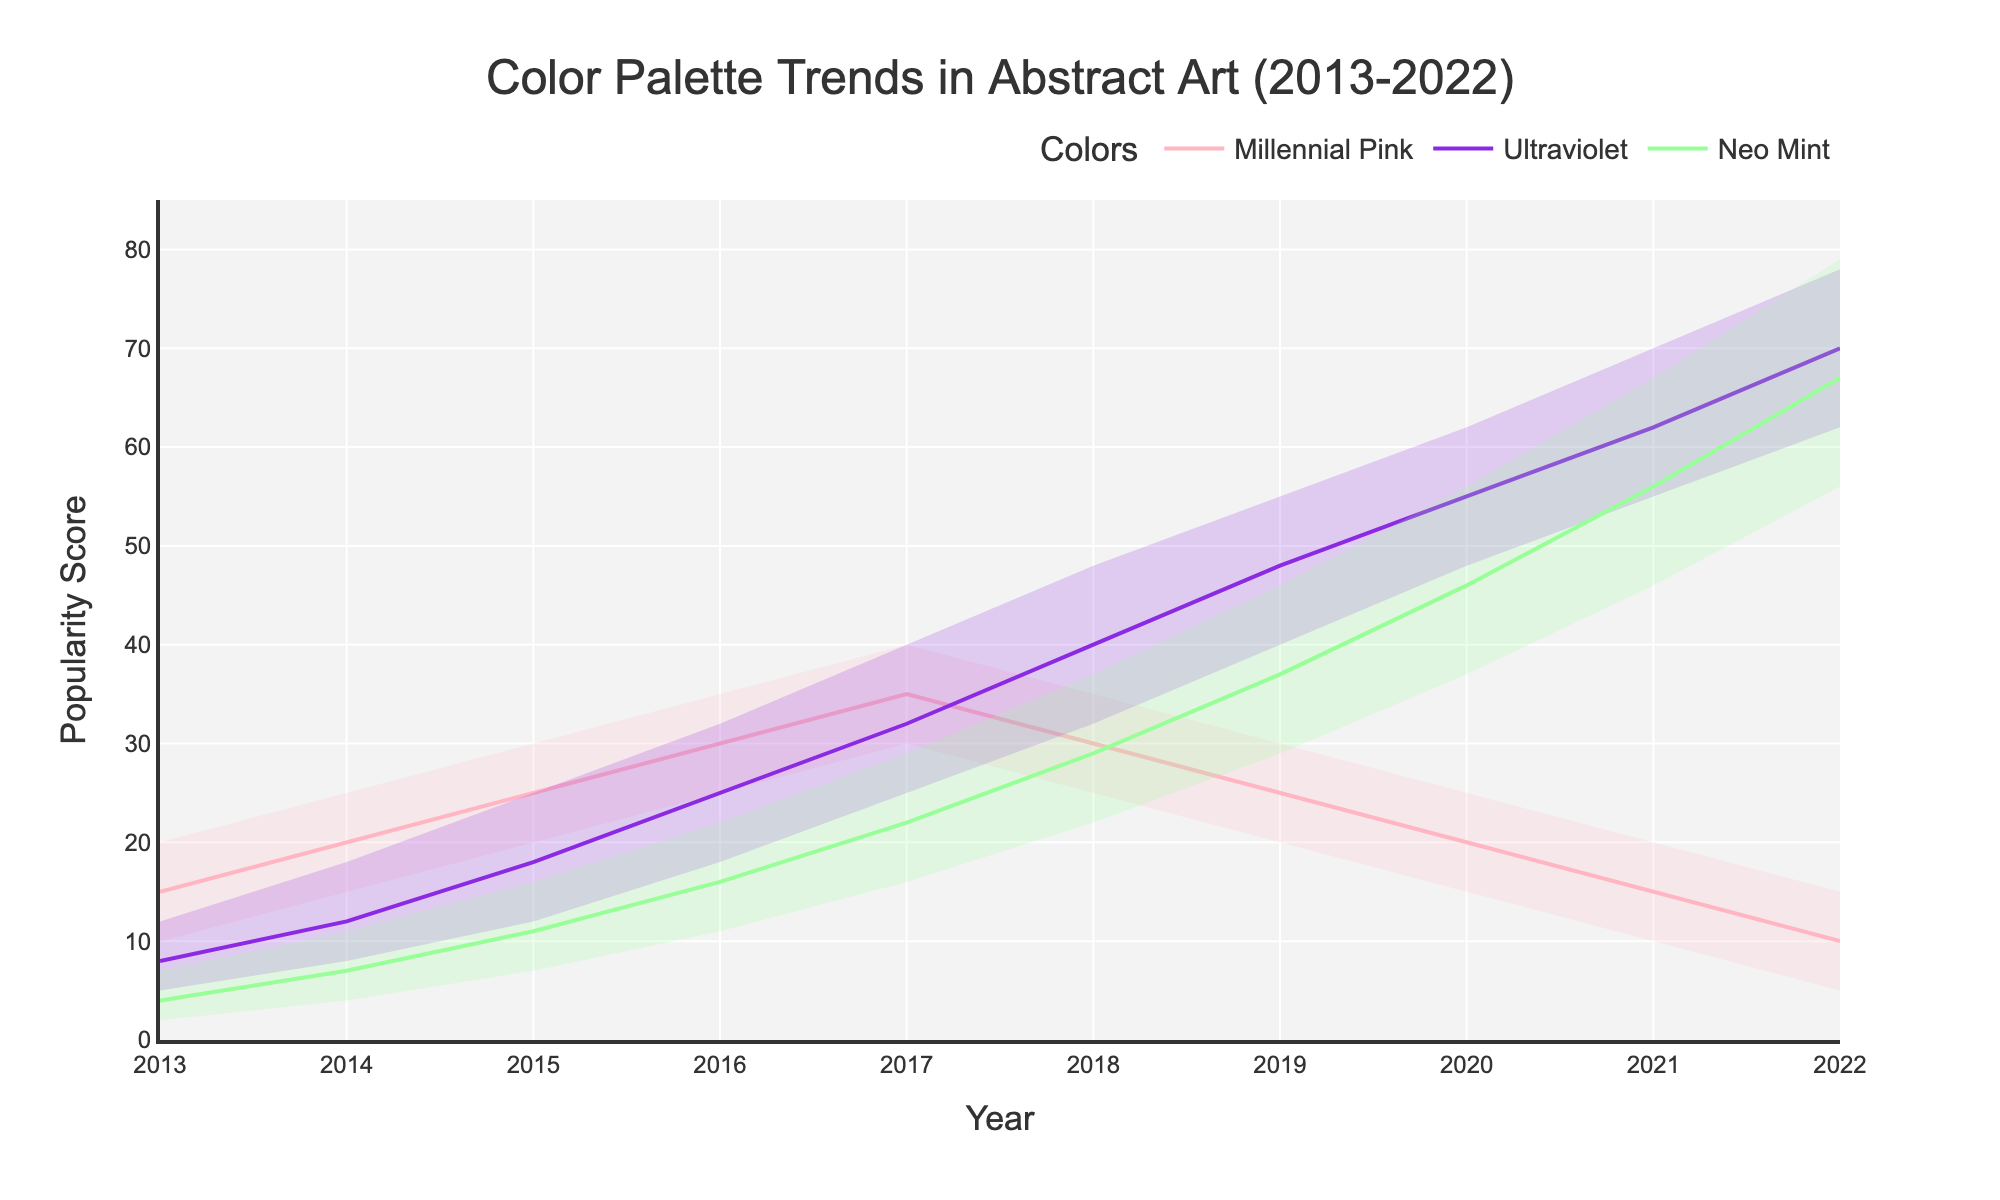What is the title of the chart? The title is displayed prominently at the top of the chart. It is meant to give a clear understanding of what the chart is about.
Answer: Color Palette Trends in Abstract Art (2013-2022) What are the colors being compared in the chart? The legend at the bottom of the chart shows the different colors being tracked. Each color also has a different line plot.
Answer: Millennial Pink, Ultraviolet, Neo Mint Which color had the highest popularity score in 2022? Look at the lines for each color in the year 2022. The topmost point among the three colors indicates the highest popularity score.
Answer: Ultraviolet How did the popularity of Neo Mint change from 2013 to 2022? Trace the line for Neo Mint from 2013 to 2022. Note the consistent increase in the mid values each year to see the trend.
Answer: Increased Which color showed a decline in popularity over the entire period? Examine the color lines from start to finish and identify which one has a descending trend towards 2022.
Answer: Millennial Pink What was the popularity score range for Ultraviolet in 2020? Look at the top and bottom boundaries of the fan chart for Ultraviolet in 2020. These represent the high and low scores.
Answer: 48 to 62 Compare the mid value of Millennial Pink in 2018 to its mid value in 2021. Which year had a higher mid value? Locate the mid value for Millennial Pink in 2018 and compare it by looking at the same color line in 2021.
Answer: 2018 Which year shows the highest average popularity score for all three colors combined? For each year, sum the mid values of the three colors and compare these sums across all years. This will show which year had the highest combined average.
Answer: 2017 How many years did Neo Mint's popularity score range overlap with Ultraviolet's? Look at the fan chart areas for Neo Mint and Ultraviolet. Identify the years during which their high and low boundaries intersect.
Answer: 3 years (2018, 2019, 2020) Which color had the most consistent popularity trend over the decade? Examine the lines for each color over the entire time period and identify which line shows the least fluctuation.
Answer: Neo Mint 